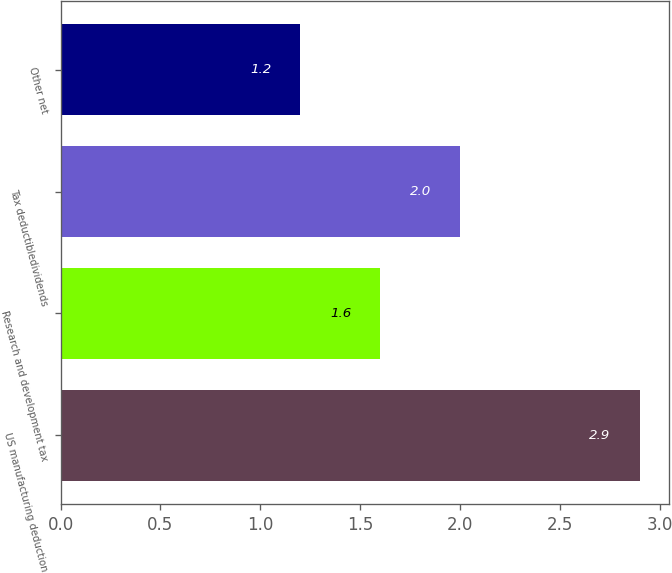<chart> <loc_0><loc_0><loc_500><loc_500><bar_chart><fcel>US manufacturing deduction<fcel>Research and development tax<fcel>Tax deductibledividends<fcel>Other net<nl><fcel>2.9<fcel>1.6<fcel>2<fcel>1.2<nl></chart> 